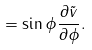Convert formula to latex. <formula><loc_0><loc_0><loc_500><loc_500>= \sin \phi \frac { \partial \tilde { v } } { \partial \phi } .</formula> 